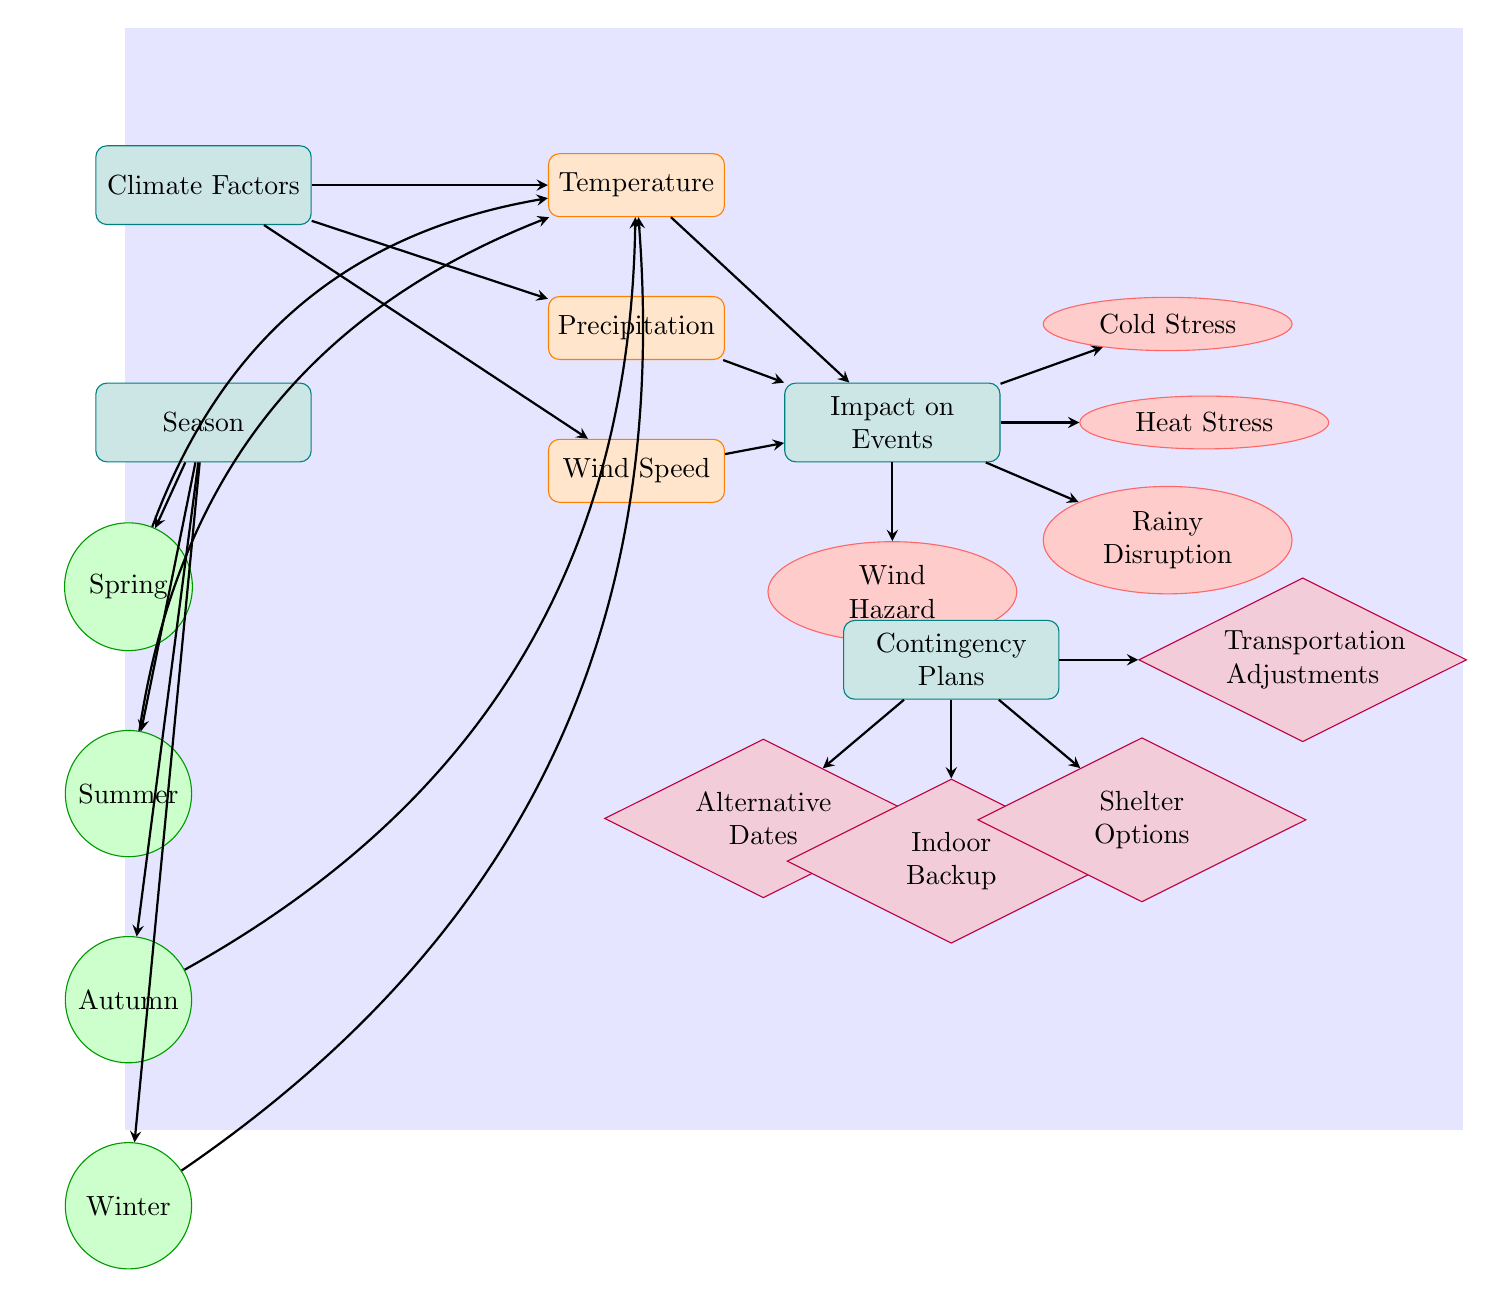What are the three climate factors represented in the diagram? The climate factors shown are temperature, precipitation, and wind speed. These factors are visually represented as nodes that branch out from the main category of climate factors.
Answer: temperature, precipitation, wind speed How many seasons are represented in the diagram? There are four seasons depicted: spring, summer, autumn, and winter. They are shown as separate nodes below the season category.
Answer: 4 What impact is directly associated with high temperatures? The impact associated with high temperatures is heat stress, which is shown as a node branching out from the impact on events category.
Answer: Heat Stress Which contingency plan is related to outdoor weather disruptions? The contingency plan related to outdoor weather disruptions that can be implemented is indoor backup, indicating a strategy for adverse weather conditions.
Answer: Indoor Backup What is the relationship between precipitation and rainy disruption? Precipitation affects event planning directly, as illustrated by an arrow leading from the precipitation node to the rainy disruption node, indicating that increased precipitation leads to rainy disruption during events.
Answer: Directly affects How are the contingency plan nodes connected to the impact on events? The contingency plan nodes are not directly connected to the impact on events; instead, they serve as separate strategies that can be applied in response to the impacts (like cold stress, heat stress, etc.), showing how planners can prepare for adverse effects of weather.
Answer: Not directly connected Which external factors primarily lead to cold stress in events? Cold stress arises mainly from temperature fluctuations during colder seasons, particularly in winter, as shown by the flow of information in the diagram highlighting that cold weather impacts events.
Answer: Temperature What type of diagram is this? This is a Natural Science Diagram that analyzes the relationships between climate patterns and their effects on event planning. The structure of categories, impacts, and plans is typical for understanding scientific principles visually.
Answer: Natural Science Diagram 